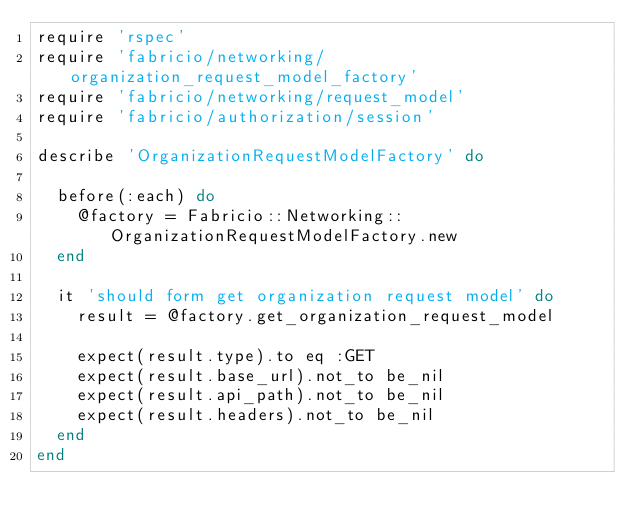<code> <loc_0><loc_0><loc_500><loc_500><_Ruby_>require 'rspec'
require 'fabricio/networking/organization_request_model_factory'
require 'fabricio/networking/request_model'
require 'fabricio/authorization/session'

describe 'OrganizationRequestModelFactory' do

  before(:each) do
    @factory = Fabricio::Networking::OrganizationRequestModelFactory.new
  end

  it 'should form get organization request model' do
    result = @factory.get_organization_request_model

    expect(result.type).to eq :GET
    expect(result.base_url).not_to be_nil
    expect(result.api_path).not_to be_nil
    expect(result.headers).not_to be_nil
  end
end</code> 